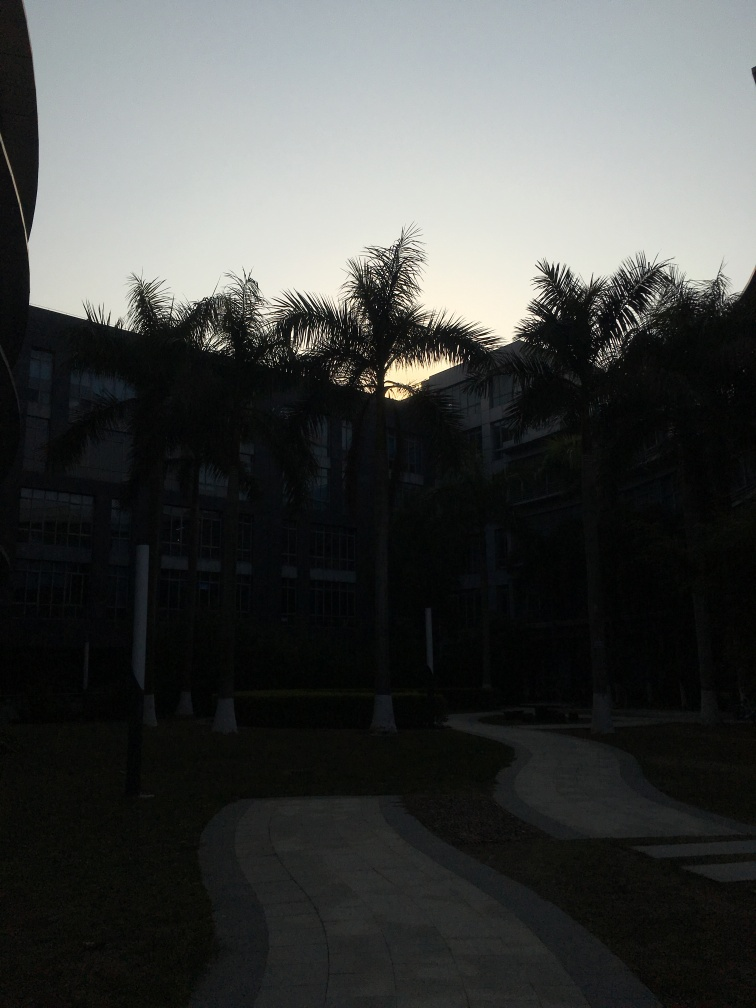What architectural style does the house exhibit? Based on the visible elements of the building, with its straight lines and what seem to be rectangular windows, the architecture could be described as modernistic with functional traits. However, a clearer image or more information would be needed for a precise classification. Is this location more likely to be found in a rural or urban setting? Given the structured layout of the pathways, manicured lawn, and the size and style of the building, it's more likely to be an urban setting, possibly a part of an educational institution or a corporate complex. The absence of natural wild growth or farmland typically found in rural areas supports this assumption. 